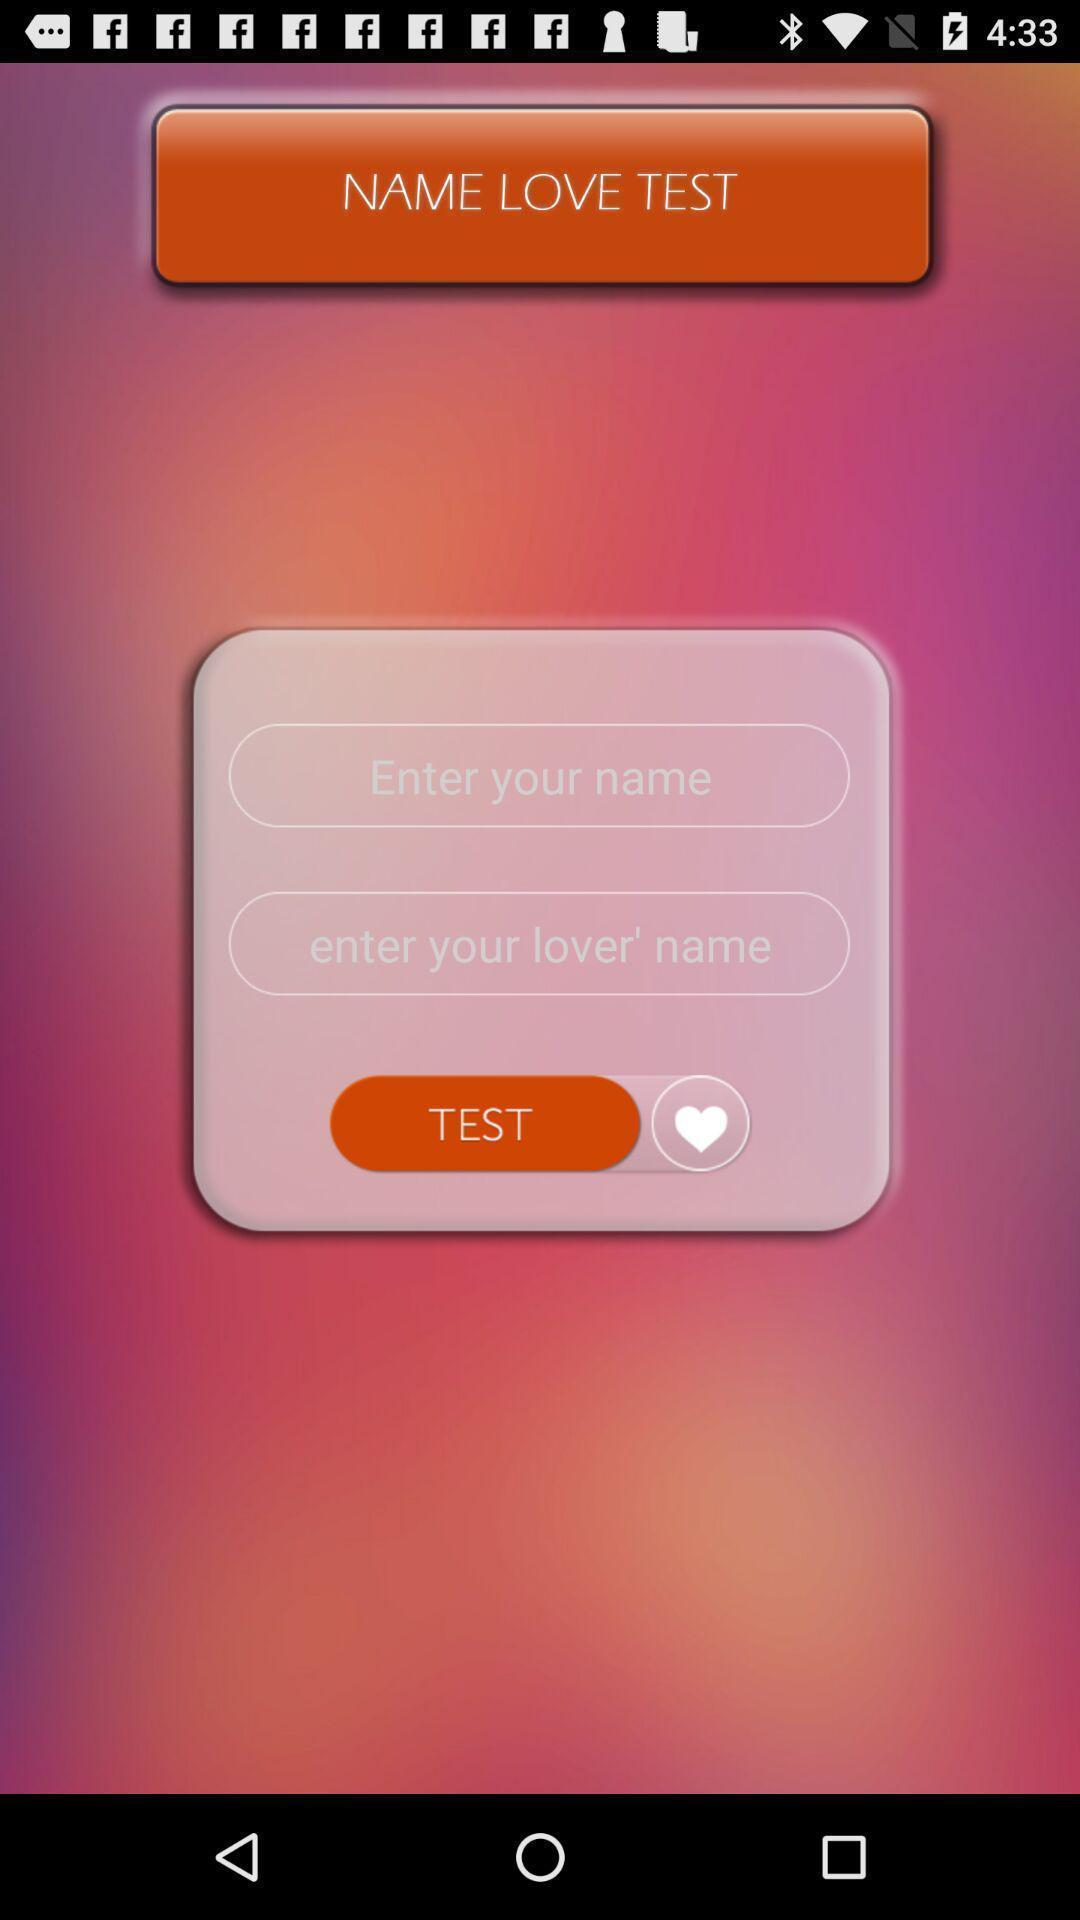Describe the key features of this screenshot. Pop-up showing love test in social app. 